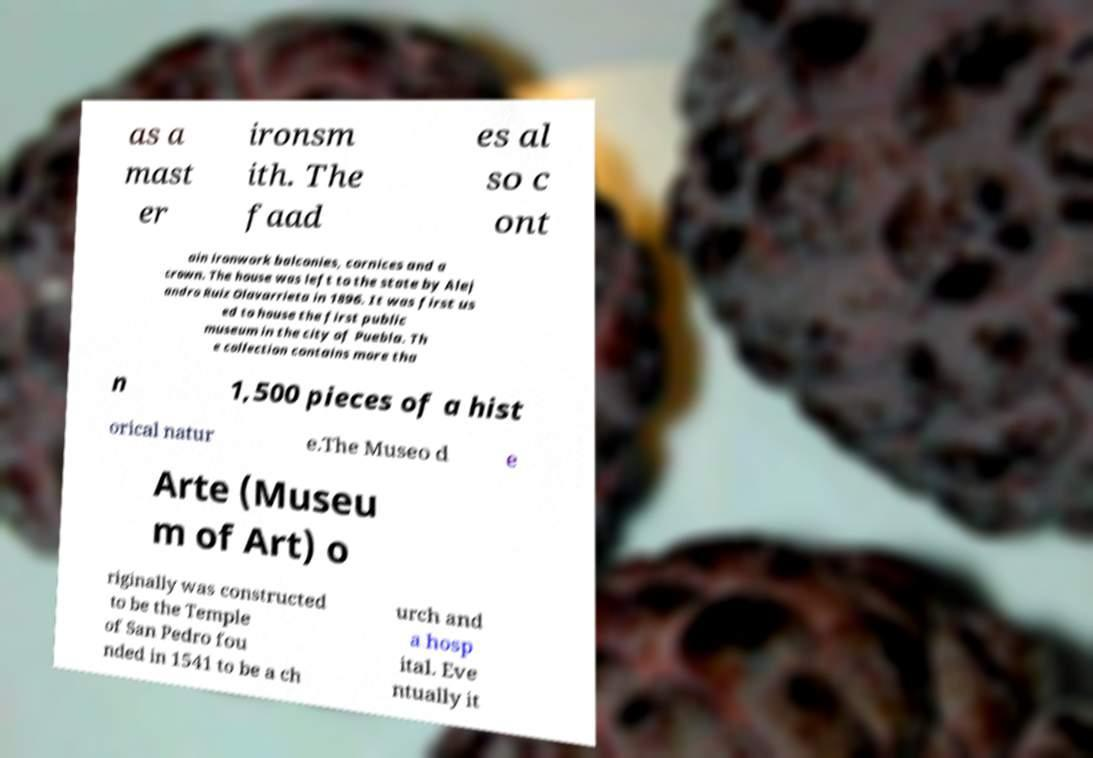Please read and relay the text visible in this image. What does it say? as a mast er ironsm ith. The faad es al so c ont ain ironwork balconies, cornices and a crown. The house was left to the state by Alej andro Ruiz Olavarrieta in 1896. It was first us ed to house the first public museum in the city of Puebla. Th e collection contains more tha n 1,500 pieces of a hist orical natur e.The Museo d e Arte (Museu m of Art) o riginally was constructed to be the Temple of San Pedro fou nded in 1541 to be a ch urch and a hosp ital. Eve ntually it 